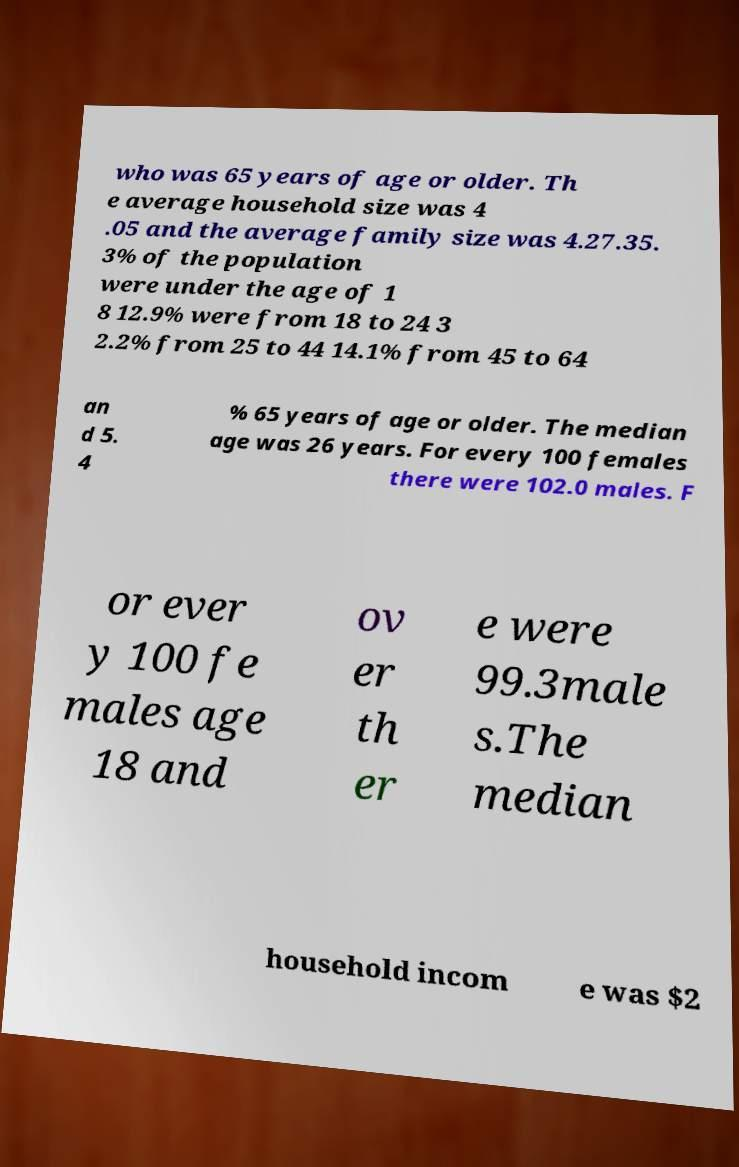Can you accurately transcribe the text from the provided image for me? who was 65 years of age or older. Th e average household size was 4 .05 and the average family size was 4.27.35. 3% of the population were under the age of 1 8 12.9% were from 18 to 24 3 2.2% from 25 to 44 14.1% from 45 to 64 an d 5. 4 % 65 years of age or older. The median age was 26 years. For every 100 females there were 102.0 males. F or ever y 100 fe males age 18 and ov er th er e were 99.3male s.The median household incom e was $2 